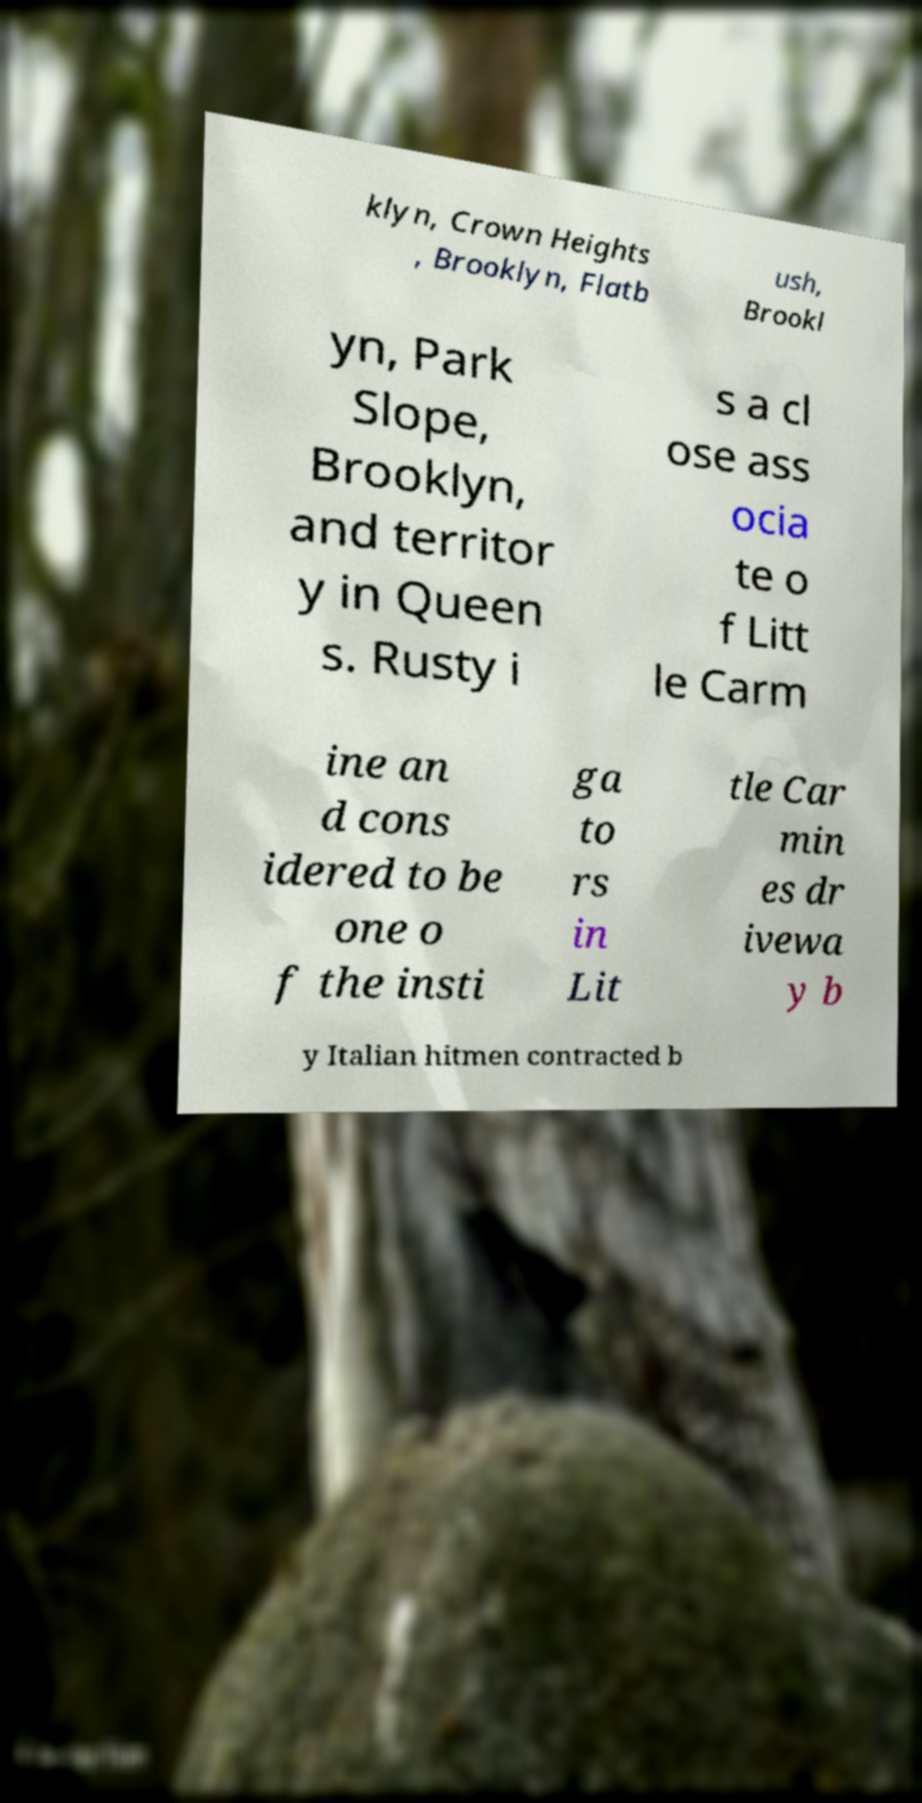Could you extract and type out the text from this image? klyn, Crown Heights , Brooklyn, Flatb ush, Brookl yn, Park Slope, Brooklyn, and territor y in Queen s. Rusty i s a cl ose ass ocia te o f Litt le Carm ine an d cons idered to be one o f the insti ga to rs in Lit tle Car min es dr ivewa y b y Italian hitmen contracted b 